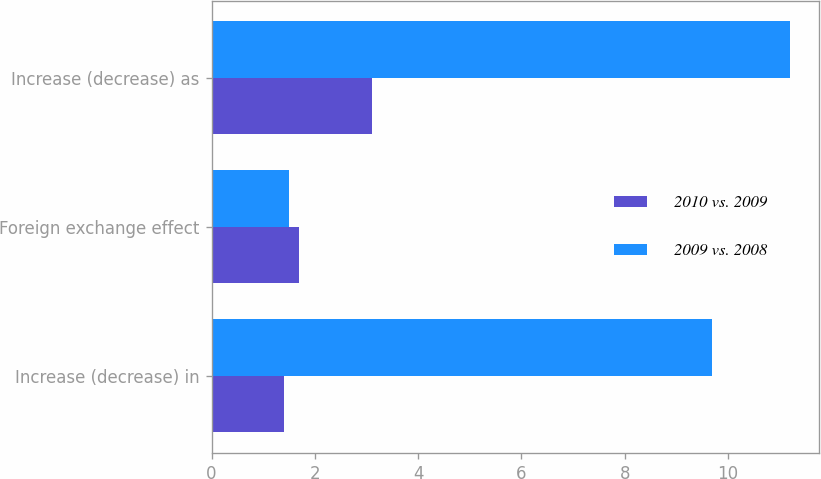<chart> <loc_0><loc_0><loc_500><loc_500><stacked_bar_chart><ecel><fcel>Increase (decrease) in<fcel>Foreign exchange effect<fcel>Increase (decrease) as<nl><fcel>2010 vs. 2009<fcel>1.4<fcel>1.7<fcel>3.1<nl><fcel>2009 vs. 2008<fcel>9.7<fcel>1.5<fcel>11.2<nl></chart> 